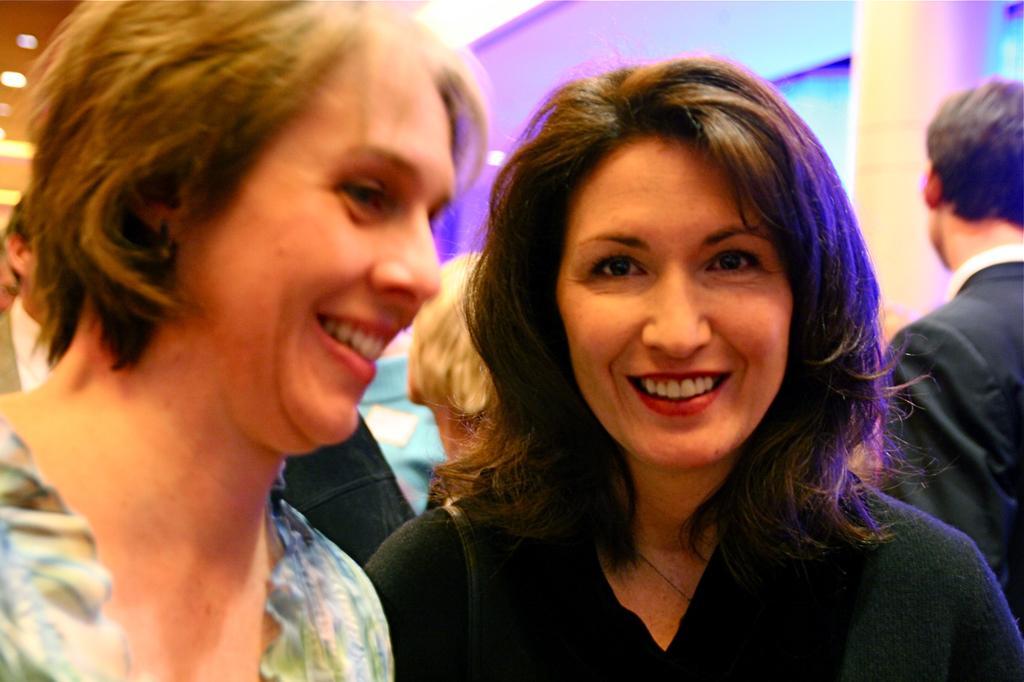Please provide a concise description of this image. In the picture I can see a woman is smiling and is on the left side of the image and another woman wearing black dress is standing on the right side of the image and smiling. In the background, we can see a few more people, we can see the pillars and lights. 